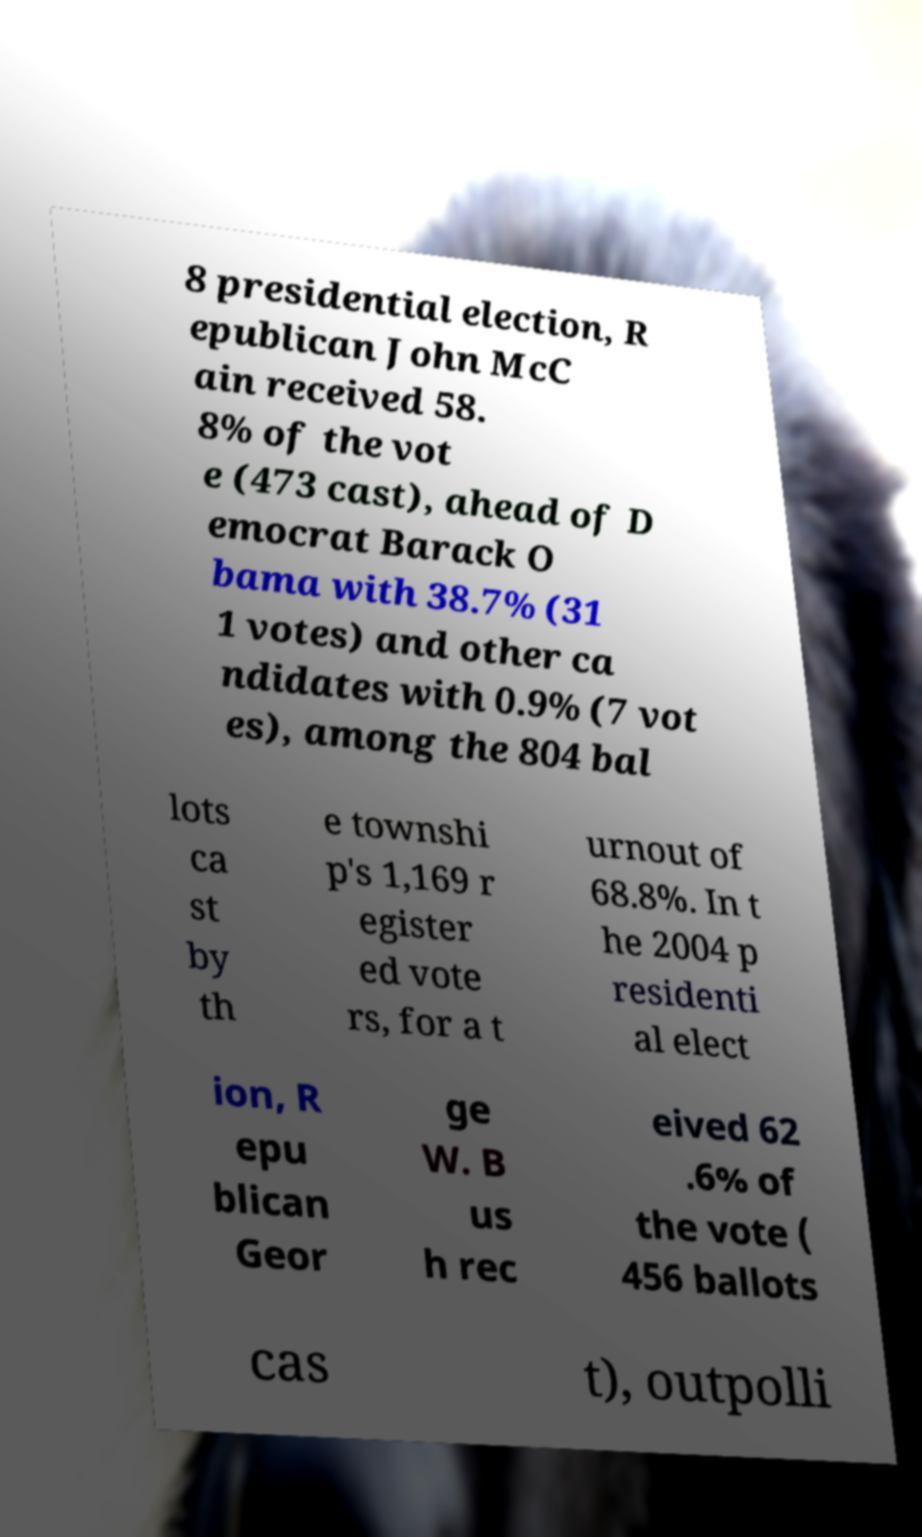What messages or text are displayed in this image? I need them in a readable, typed format. 8 presidential election, R epublican John McC ain received 58. 8% of the vot e (473 cast), ahead of D emocrat Barack O bama with 38.7% (31 1 votes) and other ca ndidates with 0.9% (7 vot es), among the 804 bal lots ca st by th e townshi p's 1,169 r egister ed vote rs, for a t urnout of 68.8%. In t he 2004 p residenti al elect ion, R epu blican Geor ge W. B us h rec eived 62 .6% of the vote ( 456 ballots cas t), outpolli 